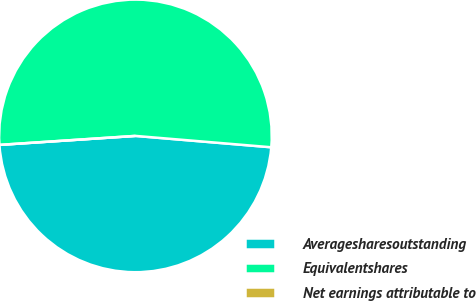<chart> <loc_0><loc_0><loc_500><loc_500><pie_chart><fcel>Averagesharesoutstanding<fcel>Equivalentshares<fcel>Net earnings attributable to<nl><fcel>47.62%<fcel>52.38%<fcel>0.0%<nl></chart> 